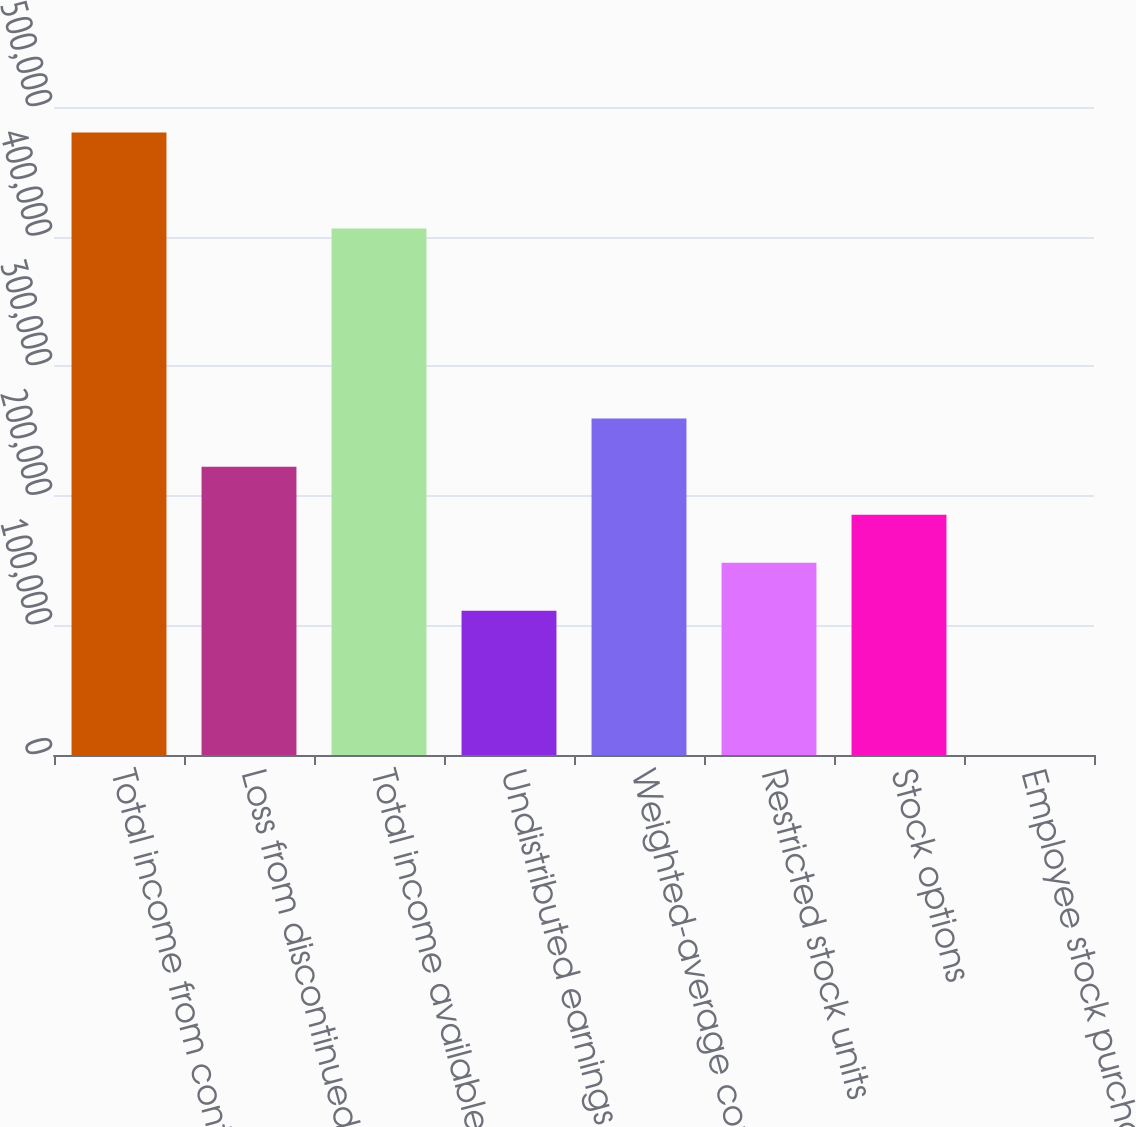<chart> <loc_0><loc_0><loc_500><loc_500><bar_chart><fcel>Total income from continuing<fcel>Loss from discontinued<fcel>Total income available to<fcel>Undistributed earnings for<fcel>Weighted-average common shares<fcel>Restricted stock units<fcel>Stock options<fcel>Employee stock purchase plan<nl><fcel>480355<fcel>222471<fcel>406198<fcel>111237<fcel>259549<fcel>148315<fcel>185393<fcel>2<nl></chart> 